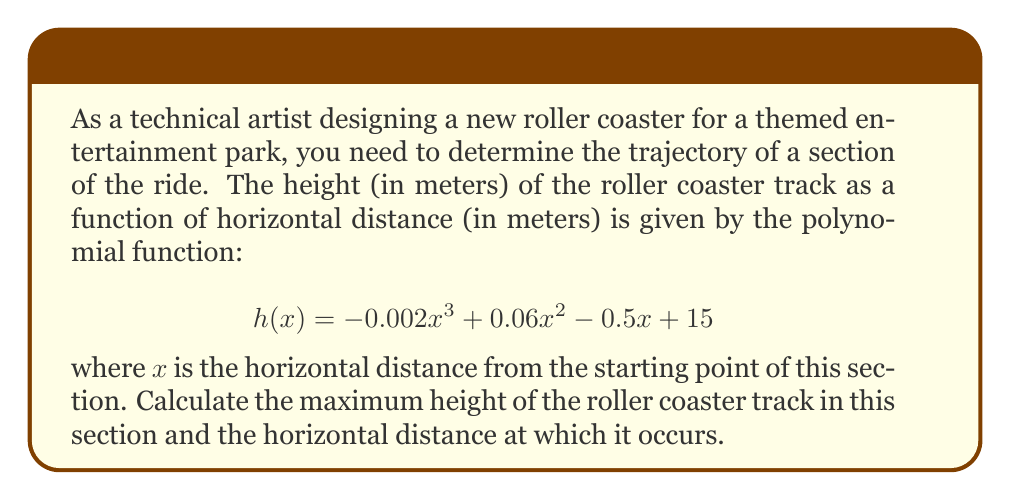Provide a solution to this math problem. To find the maximum height of the roller coaster track, we need to determine the vertex of the polynomial function. Since this is a cubic function, we'll use calculus to find the maximum point.

1. Find the first derivative of $h(x)$:
   $$h'(x) = -0.006x^2 + 0.12x - 0.5$$

2. Set $h'(x) = 0$ to find the critical points:
   $$-0.006x^2 + 0.12x - 0.5 = 0$$

3. Solve the quadratic equation:
   $$x = \frac{-b \pm \sqrt{b^2 - 4ac}}{2a}$$
   where $a = -0.006$, $b = 0.12$, and $c = -0.5$

   $$x = \frac{-0.12 \pm \sqrt{0.12^2 - 4(-0.006)(-0.5)}}{2(-0.006)}$$
   $$x = \frac{-0.12 \pm \sqrt{0.0144 - 0.012}}{-0.012}$$
   $$x = \frac{-0.12 \pm \sqrt{0.0024}}{-0.012}$$
   $$x = \frac{-0.12 \pm 0.049}{-0.012}$$

4. This gives us two solutions:
   $$x_1 = \frac{-0.12 + 0.049}{-0.012} \approx 5.92$$
   $$x_2 = \frac{-0.12 - 0.049}{-0.012} \approx 14.08$$

5. To determine which solution gives the maximum height, we can check the second derivative:
   $$h''(x) = -0.012x + 0.12$$

   At $x = 5.92$: $h''(5.92) = -0.12x + 0.12 \approx 0.049 > 0$
   At $x = 14.08$: $h''(14.08) = -0.12x + 0.12 \approx -0.049 < 0$

   Since $h''(5.92) > 0$, this point is a local minimum. Therefore, $x = 14.08$ gives us the maximum height.

6. Calculate the maximum height by plugging $x = 14.08$ into the original function:
   $$h(14.08) = -0.002(14.08)^3 + 0.06(14.08)^2 - 0.5(14.08) + 15 \approx 16.34$$

Therefore, the maximum height of the roller coaster track is approximately 16.34 meters, occurring at a horizontal distance of 14.08 meters from the starting point of this section.
Answer: The maximum height of the roller coaster track is approximately 16.34 meters, occurring at a horizontal distance of 14.08 meters from the starting point of the section. 